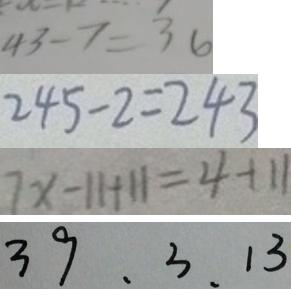Convert formula to latex. <formula><loc_0><loc_0><loc_500><loc_500>4 3 - 7 = 3 6 
 2 4 5 - 2 = 2 4 3 
 7 x - 1 1 + 1 1 = 4 + 1 1 
 3 9 , 3 , 1 3</formula> 